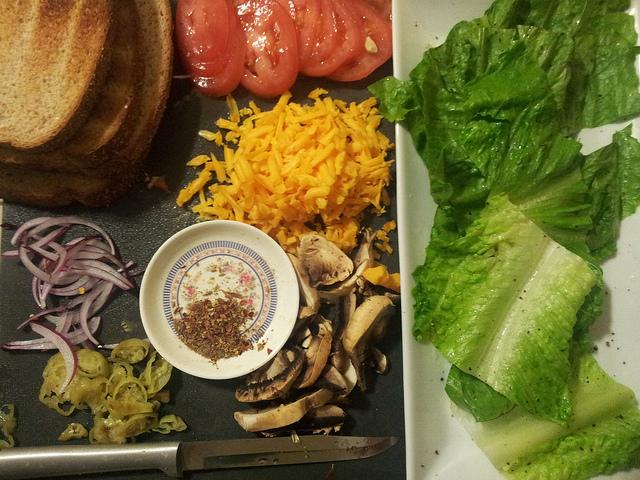Which item in this picture could be a weapon?
Give a very brief answer. Knife. Are there any fruits here?
Keep it brief. No. How has the cheese been prepared?
Give a very brief answer. Shredded. 